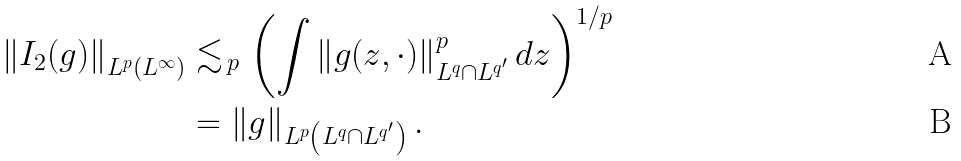Convert formula to latex. <formula><loc_0><loc_0><loc_500><loc_500>\left \| I _ { 2 } ( g ) \right \| _ { L ^ { p } \left ( L ^ { \infty } \right ) } & \lesssim _ { \, p } \left ( \int \left \| g ( z , \cdot ) \right \| _ { L ^ { q } \cap L ^ { q ^ { \prime } } } ^ { p } d z \right ) ^ { 1 / p } \\ & = \left \| g \right \| _ { L ^ { p } \left ( L ^ { q } \cap L ^ { q ^ { \prime } } \right ) } .</formula> 